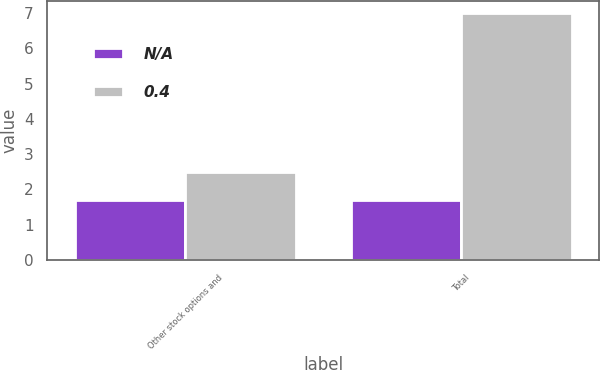Convert chart. <chart><loc_0><loc_0><loc_500><loc_500><stacked_bar_chart><ecel><fcel>Other stock options and<fcel>Total<nl><fcel>nan<fcel>1.7<fcel>1.7<nl><fcel>0.4<fcel>2.5<fcel>7<nl></chart> 